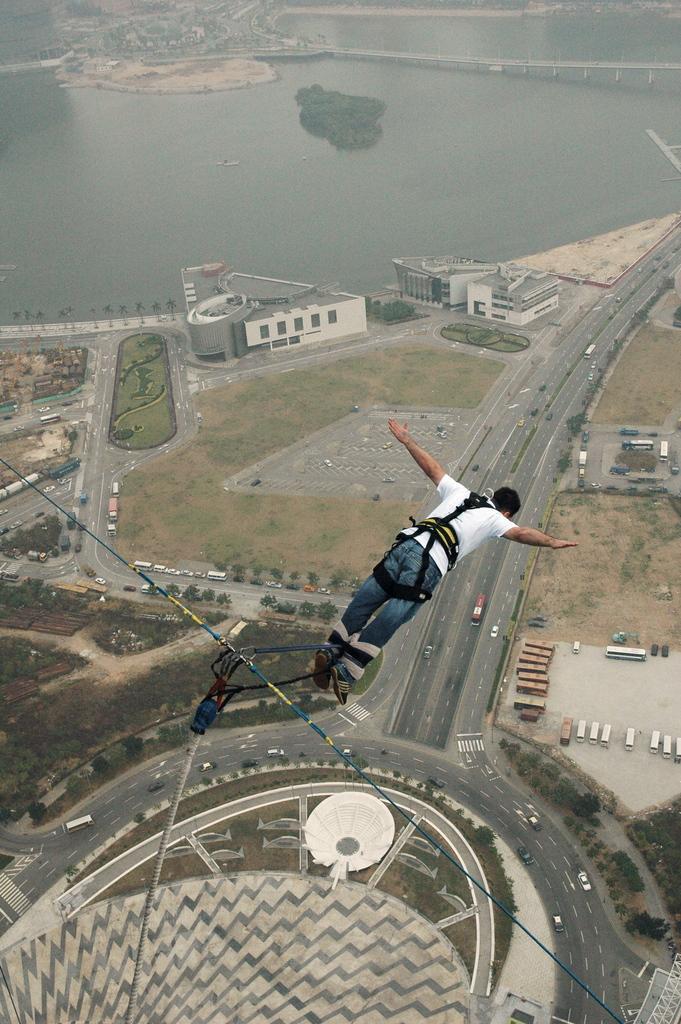Please provide a concise description of this image. In this picture we can see a man is jumping, and he is tied with cables, and we can see few vehicles on the road, in the background we can find buildings, trees and water. 